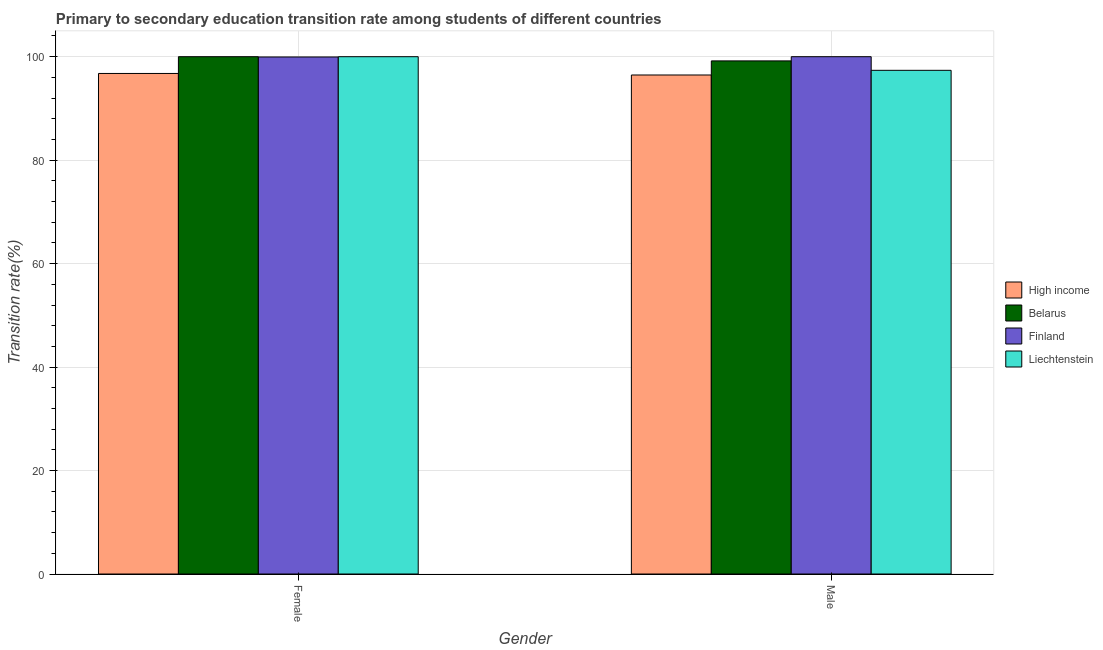How many different coloured bars are there?
Give a very brief answer. 4. Are the number of bars per tick equal to the number of legend labels?
Your answer should be very brief. Yes. How many bars are there on the 1st tick from the left?
Provide a short and direct response. 4. How many bars are there on the 1st tick from the right?
Offer a very short reply. 4. What is the label of the 2nd group of bars from the left?
Make the answer very short. Male. What is the transition rate among female students in Finland?
Offer a very short reply. 99.95. Across all countries, what is the maximum transition rate among male students?
Your answer should be compact. 100. Across all countries, what is the minimum transition rate among male students?
Offer a very short reply. 96.46. In which country was the transition rate among male students maximum?
Your response must be concise. Finland. In which country was the transition rate among female students minimum?
Ensure brevity in your answer.  High income. What is the total transition rate among male students in the graph?
Keep it short and to the point. 393.02. What is the difference between the transition rate among male students in High income and that in Finland?
Offer a very short reply. -3.54. What is the difference between the transition rate among male students in Belarus and the transition rate among female students in Finland?
Ensure brevity in your answer.  -0.76. What is the average transition rate among male students per country?
Your answer should be compact. 98.25. What is the difference between the transition rate among female students and transition rate among male students in Finland?
Offer a very short reply. -0.05. In how many countries, is the transition rate among female students greater than 72 %?
Your answer should be compact. 4. In how many countries, is the transition rate among female students greater than the average transition rate among female students taken over all countries?
Provide a succinct answer. 3. What does the 2nd bar from the left in Female represents?
Your answer should be compact. Belarus. How many bars are there?
Offer a terse response. 8. Are all the bars in the graph horizontal?
Provide a short and direct response. No. How many countries are there in the graph?
Offer a very short reply. 4. What is the difference between two consecutive major ticks on the Y-axis?
Offer a very short reply. 20. Are the values on the major ticks of Y-axis written in scientific E-notation?
Your answer should be compact. No. Does the graph contain any zero values?
Provide a succinct answer. No. Where does the legend appear in the graph?
Offer a very short reply. Center right. What is the title of the graph?
Offer a very short reply. Primary to secondary education transition rate among students of different countries. Does "South Africa" appear as one of the legend labels in the graph?
Your response must be concise. No. What is the label or title of the X-axis?
Keep it short and to the point. Gender. What is the label or title of the Y-axis?
Offer a very short reply. Transition rate(%). What is the Transition rate(%) in High income in Female?
Offer a terse response. 96.76. What is the Transition rate(%) in Belarus in Female?
Ensure brevity in your answer.  100. What is the Transition rate(%) in Finland in Female?
Offer a very short reply. 99.95. What is the Transition rate(%) of Liechtenstein in Female?
Your response must be concise. 100. What is the Transition rate(%) of High income in Male?
Provide a short and direct response. 96.46. What is the Transition rate(%) in Belarus in Male?
Make the answer very short. 99.19. What is the Transition rate(%) in Liechtenstein in Male?
Offer a terse response. 97.37. Across all Gender, what is the maximum Transition rate(%) in High income?
Offer a very short reply. 96.76. Across all Gender, what is the maximum Transition rate(%) in Belarus?
Offer a terse response. 100. Across all Gender, what is the maximum Transition rate(%) of Finland?
Make the answer very short. 100. Across all Gender, what is the minimum Transition rate(%) of High income?
Give a very brief answer. 96.46. Across all Gender, what is the minimum Transition rate(%) of Belarus?
Make the answer very short. 99.19. Across all Gender, what is the minimum Transition rate(%) of Finland?
Your response must be concise. 99.95. Across all Gender, what is the minimum Transition rate(%) of Liechtenstein?
Ensure brevity in your answer.  97.37. What is the total Transition rate(%) in High income in the graph?
Your answer should be very brief. 193.22. What is the total Transition rate(%) of Belarus in the graph?
Offer a very short reply. 199.19. What is the total Transition rate(%) in Finland in the graph?
Make the answer very short. 199.95. What is the total Transition rate(%) in Liechtenstein in the graph?
Your response must be concise. 197.37. What is the difference between the Transition rate(%) in High income in Female and that in Male?
Make the answer very short. 0.3. What is the difference between the Transition rate(%) in Belarus in Female and that in Male?
Provide a succinct answer. 0.81. What is the difference between the Transition rate(%) of Finland in Female and that in Male?
Your answer should be very brief. -0.05. What is the difference between the Transition rate(%) in Liechtenstein in Female and that in Male?
Provide a succinct answer. 2.63. What is the difference between the Transition rate(%) of High income in Female and the Transition rate(%) of Belarus in Male?
Keep it short and to the point. -2.43. What is the difference between the Transition rate(%) in High income in Female and the Transition rate(%) in Finland in Male?
Provide a short and direct response. -3.24. What is the difference between the Transition rate(%) in High income in Female and the Transition rate(%) in Liechtenstein in Male?
Make the answer very short. -0.61. What is the difference between the Transition rate(%) in Belarus in Female and the Transition rate(%) in Liechtenstein in Male?
Make the answer very short. 2.63. What is the difference between the Transition rate(%) in Finland in Female and the Transition rate(%) in Liechtenstein in Male?
Keep it short and to the point. 2.58. What is the average Transition rate(%) of High income per Gender?
Provide a succinct answer. 96.61. What is the average Transition rate(%) in Belarus per Gender?
Offer a very short reply. 99.59. What is the average Transition rate(%) in Finland per Gender?
Offer a very short reply. 99.97. What is the average Transition rate(%) in Liechtenstein per Gender?
Your answer should be compact. 98.68. What is the difference between the Transition rate(%) in High income and Transition rate(%) in Belarus in Female?
Ensure brevity in your answer.  -3.24. What is the difference between the Transition rate(%) in High income and Transition rate(%) in Finland in Female?
Your response must be concise. -3.19. What is the difference between the Transition rate(%) of High income and Transition rate(%) of Liechtenstein in Female?
Make the answer very short. -3.24. What is the difference between the Transition rate(%) of Belarus and Transition rate(%) of Finland in Female?
Offer a very short reply. 0.05. What is the difference between the Transition rate(%) of Finland and Transition rate(%) of Liechtenstein in Female?
Provide a short and direct response. -0.05. What is the difference between the Transition rate(%) of High income and Transition rate(%) of Belarus in Male?
Keep it short and to the point. -2.72. What is the difference between the Transition rate(%) in High income and Transition rate(%) in Finland in Male?
Offer a very short reply. -3.54. What is the difference between the Transition rate(%) in High income and Transition rate(%) in Liechtenstein in Male?
Ensure brevity in your answer.  -0.9. What is the difference between the Transition rate(%) in Belarus and Transition rate(%) in Finland in Male?
Keep it short and to the point. -0.81. What is the difference between the Transition rate(%) of Belarus and Transition rate(%) of Liechtenstein in Male?
Make the answer very short. 1.82. What is the difference between the Transition rate(%) in Finland and Transition rate(%) in Liechtenstein in Male?
Ensure brevity in your answer.  2.63. What is the ratio of the Transition rate(%) of High income in Female to that in Male?
Provide a short and direct response. 1. What is the ratio of the Transition rate(%) in Belarus in Female to that in Male?
Ensure brevity in your answer.  1.01. What is the ratio of the Transition rate(%) in Finland in Female to that in Male?
Keep it short and to the point. 1. What is the difference between the highest and the second highest Transition rate(%) of High income?
Your answer should be very brief. 0.3. What is the difference between the highest and the second highest Transition rate(%) in Belarus?
Offer a terse response. 0.81. What is the difference between the highest and the second highest Transition rate(%) in Finland?
Keep it short and to the point. 0.05. What is the difference between the highest and the second highest Transition rate(%) in Liechtenstein?
Your answer should be very brief. 2.63. What is the difference between the highest and the lowest Transition rate(%) in High income?
Your answer should be compact. 0.3. What is the difference between the highest and the lowest Transition rate(%) in Belarus?
Make the answer very short. 0.81. What is the difference between the highest and the lowest Transition rate(%) in Finland?
Your answer should be compact. 0.05. What is the difference between the highest and the lowest Transition rate(%) in Liechtenstein?
Your response must be concise. 2.63. 